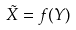<formula> <loc_0><loc_0><loc_500><loc_500>\tilde { X } = f ( Y )</formula> 